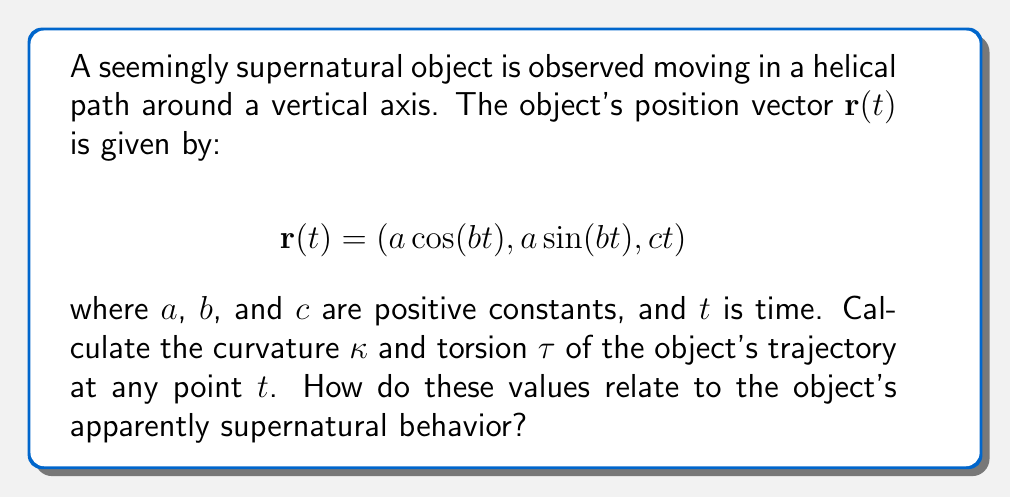Show me your answer to this math problem. To analyze the trajectory of this seemingly supernatural object using differential geometry, we need to calculate the curvature and torsion of its path. These parameters will help us understand the object's motion in 3D space.

1. First, let's calculate the velocity vector $\mathbf{v}(t)$ by differentiating $\mathbf{r}(t)$:

   $$\mathbf{v}(t) = \mathbf{r}'(t) = (-ab \sin(bt), ab \cos(bt), c)$$

2. Now, let's calculate the acceleration vector $\mathbf{a}(t)$ by differentiating $\mathbf{v}(t)$:

   $$\mathbf{a}(t) = \mathbf{v}'(t) = (-ab^2 \cos(bt), -ab^2 \sin(bt), 0)$$

3. To calculate curvature, we need the magnitude of velocity and the cross product of velocity and acceleration:

   $$\|\mathbf{v}(t)\| = \sqrt{(ab)^2 + c^2}$$

   $$\|\mathbf{v}(t) \times \mathbf{a}(t)\| = ab^2c$$

4. The curvature $\kappa$ is given by:

   $$\kappa = \frac{\|\mathbf{v}(t) \times \mathbf{a}(t)\|}{\|\mathbf{v}(t)\|^3} = \frac{ab^2c}{((ab)^2 + c^2)^{3/2}}$$

5. To calculate torsion, we need the triple scalar product of velocity, acceleration, and jerk (the derivative of acceleration):

   $$\mathbf{j}(t) = \mathbf{a}'(t) = (ab^3 \sin(bt), -ab^3 \cos(bt), 0)$$

   $$[\mathbf{v}(t), \mathbf{a}(t), \mathbf{j}(t)] = -a^2b^3c$$

6. The torsion $\tau$ is given by:

   $$\tau = \frac{[\mathbf{v}(t), \mathbf{a}(t), \mathbf{j}(t)]}{\|\mathbf{v}(t) \times \mathbf{a}(t)\|^2} = \frac{-a^2b^3c}{(ab^2c)^2} = -\frac{1}{abc}$$

The constant non-zero curvature and torsion indicate that the object is moving in a perfect helical path. This seemingly supernatural behavior can be explained by the presence of a constant force acting perpendicular to the object's velocity, combined with a constant vertical velocity. The curvature $\kappa$ represents how sharply the path is curving at each point, while the torsion $\tau$ represents how much the path is twisting out of a plane.

The apparently supernatural aspect of this motion lies in its perfect regularity and consistency, which would be highly unusual for a natural object under normal circumstances. However, this analysis provides a scientific framework to describe and understand the object's motion, potentially explaining the seemingly supernatural behavior through precise mathematical modeling.
Answer: Curvature: $\kappa = \frac{ab^2c}{((ab)^2 + c^2)^{3/2}}$
Torsion: $\tau = -\frac{1}{abc}$ 